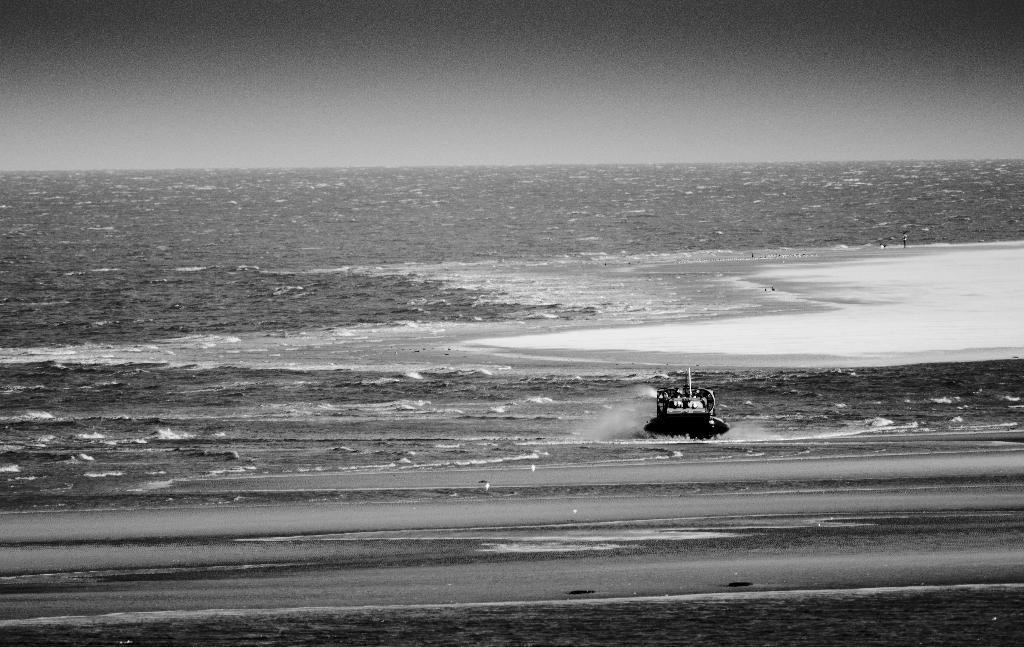What is the main subject of the image? The main subject of the image is a boat. Where is the boat located? The boat is on a river. What type of metal is used to make the crown worn by the boat in the image? There is no crown present in the image, as the boat is the main subject, and it is not wearing any crown. 